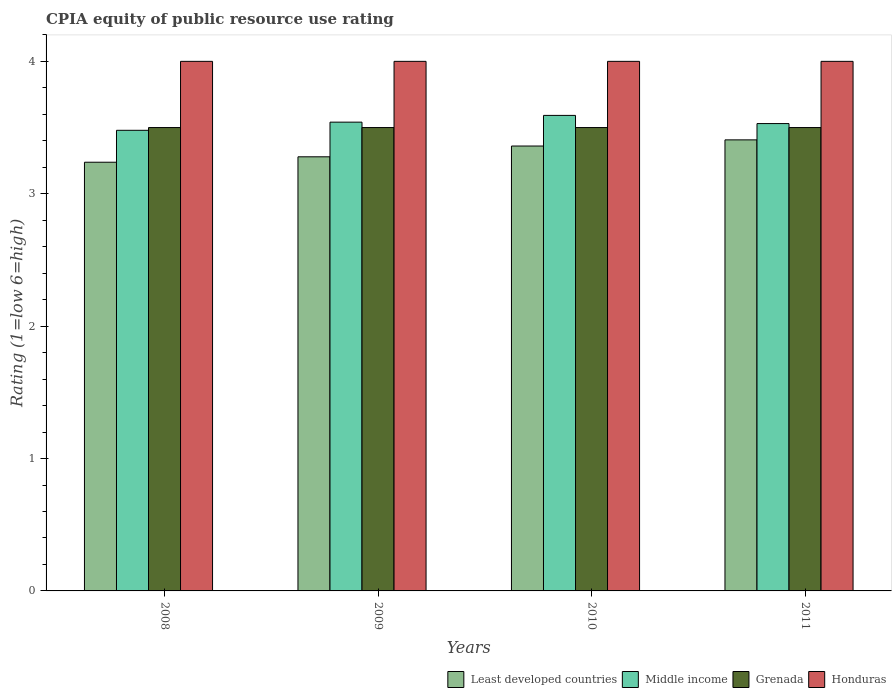Are the number of bars on each tick of the X-axis equal?
Your answer should be very brief. Yes. How many bars are there on the 3rd tick from the left?
Your response must be concise. 4. In how many cases, is the number of bars for a given year not equal to the number of legend labels?
Provide a succinct answer. 0. What is the CPIA rating in Least developed countries in 2011?
Your answer should be very brief. 3.41. Across all years, what is the maximum CPIA rating in Least developed countries?
Your answer should be very brief. 3.41. Across all years, what is the minimum CPIA rating in Honduras?
Provide a short and direct response. 4. What is the total CPIA rating in Honduras in the graph?
Your answer should be compact. 16. What is the difference between the CPIA rating in Least developed countries in 2010 and the CPIA rating in Grenada in 2009?
Keep it short and to the point. -0.14. What is the average CPIA rating in Honduras per year?
Offer a terse response. 4. In the year 2008, what is the difference between the CPIA rating in Least developed countries and CPIA rating in Honduras?
Keep it short and to the point. -0.76. In how many years, is the CPIA rating in Middle income greater than 0.4?
Keep it short and to the point. 4. What is the ratio of the CPIA rating in Honduras in 2008 to that in 2009?
Ensure brevity in your answer.  1. Is the CPIA rating in Least developed countries in 2009 less than that in 2011?
Offer a very short reply. Yes. Is the difference between the CPIA rating in Least developed countries in 2008 and 2010 greater than the difference between the CPIA rating in Honduras in 2008 and 2010?
Your answer should be very brief. No. What is the difference between the highest and the second highest CPIA rating in Middle income?
Give a very brief answer. 0.05. What is the difference between the highest and the lowest CPIA rating in Middle income?
Provide a succinct answer. 0.11. Is the sum of the CPIA rating in Honduras in 2009 and 2011 greater than the maximum CPIA rating in Least developed countries across all years?
Provide a short and direct response. Yes. What does the 3rd bar from the left in 2008 represents?
Make the answer very short. Grenada. What does the 1st bar from the right in 2011 represents?
Your response must be concise. Honduras. How many bars are there?
Offer a very short reply. 16. Does the graph contain grids?
Provide a succinct answer. No. Where does the legend appear in the graph?
Your answer should be very brief. Bottom right. How many legend labels are there?
Give a very brief answer. 4. What is the title of the graph?
Your answer should be compact. CPIA equity of public resource use rating. What is the label or title of the Y-axis?
Make the answer very short. Rating (1=low 6=high). What is the Rating (1=low 6=high) of Least developed countries in 2008?
Offer a very short reply. 3.24. What is the Rating (1=low 6=high) of Middle income in 2008?
Provide a succinct answer. 3.48. What is the Rating (1=low 6=high) of Grenada in 2008?
Give a very brief answer. 3.5. What is the Rating (1=low 6=high) in Honduras in 2008?
Your response must be concise. 4. What is the Rating (1=low 6=high) of Least developed countries in 2009?
Provide a succinct answer. 3.28. What is the Rating (1=low 6=high) of Middle income in 2009?
Ensure brevity in your answer.  3.54. What is the Rating (1=low 6=high) of Grenada in 2009?
Your answer should be compact. 3.5. What is the Rating (1=low 6=high) of Honduras in 2009?
Your answer should be compact. 4. What is the Rating (1=low 6=high) in Least developed countries in 2010?
Offer a terse response. 3.36. What is the Rating (1=low 6=high) of Middle income in 2010?
Your answer should be compact. 3.59. What is the Rating (1=low 6=high) of Honduras in 2010?
Offer a very short reply. 4. What is the Rating (1=low 6=high) in Least developed countries in 2011?
Offer a very short reply. 3.41. What is the Rating (1=low 6=high) in Middle income in 2011?
Your answer should be very brief. 3.53. What is the Rating (1=low 6=high) of Grenada in 2011?
Offer a very short reply. 3.5. Across all years, what is the maximum Rating (1=low 6=high) in Least developed countries?
Ensure brevity in your answer.  3.41. Across all years, what is the maximum Rating (1=low 6=high) of Middle income?
Provide a short and direct response. 3.59. Across all years, what is the maximum Rating (1=low 6=high) in Grenada?
Make the answer very short. 3.5. Across all years, what is the minimum Rating (1=low 6=high) of Least developed countries?
Offer a very short reply. 3.24. Across all years, what is the minimum Rating (1=low 6=high) of Middle income?
Offer a terse response. 3.48. Across all years, what is the minimum Rating (1=low 6=high) in Grenada?
Provide a succinct answer. 3.5. Across all years, what is the minimum Rating (1=low 6=high) of Honduras?
Keep it short and to the point. 4. What is the total Rating (1=low 6=high) in Least developed countries in the graph?
Make the answer very short. 13.28. What is the total Rating (1=low 6=high) in Middle income in the graph?
Offer a terse response. 14.14. What is the total Rating (1=low 6=high) of Honduras in the graph?
Keep it short and to the point. 16. What is the difference between the Rating (1=low 6=high) of Least developed countries in 2008 and that in 2009?
Make the answer very short. -0.04. What is the difference between the Rating (1=low 6=high) of Middle income in 2008 and that in 2009?
Your answer should be very brief. -0.06. What is the difference between the Rating (1=low 6=high) of Honduras in 2008 and that in 2009?
Give a very brief answer. 0. What is the difference between the Rating (1=low 6=high) of Least developed countries in 2008 and that in 2010?
Offer a very short reply. -0.12. What is the difference between the Rating (1=low 6=high) in Middle income in 2008 and that in 2010?
Offer a very short reply. -0.11. What is the difference between the Rating (1=low 6=high) in Honduras in 2008 and that in 2010?
Your answer should be compact. 0. What is the difference between the Rating (1=low 6=high) of Least developed countries in 2008 and that in 2011?
Provide a short and direct response. -0.17. What is the difference between the Rating (1=low 6=high) in Middle income in 2008 and that in 2011?
Offer a terse response. -0.05. What is the difference between the Rating (1=low 6=high) in Grenada in 2008 and that in 2011?
Give a very brief answer. 0. What is the difference between the Rating (1=low 6=high) in Least developed countries in 2009 and that in 2010?
Your response must be concise. -0.08. What is the difference between the Rating (1=low 6=high) in Middle income in 2009 and that in 2010?
Your answer should be compact. -0.05. What is the difference between the Rating (1=low 6=high) of Least developed countries in 2009 and that in 2011?
Offer a terse response. -0.13. What is the difference between the Rating (1=low 6=high) in Middle income in 2009 and that in 2011?
Your answer should be very brief. 0.01. What is the difference between the Rating (1=low 6=high) in Grenada in 2009 and that in 2011?
Your answer should be compact. 0. What is the difference between the Rating (1=low 6=high) of Honduras in 2009 and that in 2011?
Your response must be concise. 0. What is the difference between the Rating (1=low 6=high) in Least developed countries in 2010 and that in 2011?
Offer a very short reply. -0.05. What is the difference between the Rating (1=low 6=high) in Middle income in 2010 and that in 2011?
Keep it short and to the point. 0.06. What is the difference between the Rating (1=low 6=high) in Grenada in 2010 and that in 2011?
Keep it short and to the point. 0. What is the difference between the Rating (1=low 6=high) of Honduras in 2010 and that in 2011?
Keep it short and to the point. 0. What is the difference between the Rating (1=low 6=high) of Least developed countries in 2008 and the Rating (1=low 6=high) of Middle income in 2009?
Give a very brief answer. -0.3. What is the difference between the Rating (1=low 6=high) in Least developed countries in 2008 and the Rating (1=low 6=high) in Grenada in 2009?
Your response must be concise. -0.26. What is the difference between the Rating (1=low 6=high) in Least developed countries in 2008 and the Rating (1=low 6=high) in Honduras in 2009?
Your response must be concise. -0.76. What is the difference between the Rating (1=low 6=high) in Middle income in 2008 and the Rating (1=low 6=high) in Grenada in 2009?
Give a very brief answer. -0.02. What is the difference between the Rating (1=low 6=high) in Middle income in 2008 and the Rating (1=low 6=high) in Honduras in 2009?
Your response must be concise. -0.52. What is the difference between the Rating (1=low 6=high) of Least developed countries in 2008 and the Rating (1=low 6=high) of Middle income in 2010?
Your answer should be very brief. -0.35. What is the difference between the Rating (1=low 6=high) of Least developed countries in 2008 and the Rating (1=low 6=high) of Grenada in 2010?
Give a very brief answer. -0.26. What is the difference between the Rating (1=low 6=high) of Least developed countries in 2008 and the Rating (1=low 6=high) of Honduras in 2010?
Offer a terse response. -0.76. What is the difference between the Rating (1=low 6=high) in Middle income in 2008 and the Rating (1=low 6=high) in Grenada in 2010?
Provide a succinct answer. -0.02. What is the difference between the Rating (1=low 6=high) in Middle income in 2008 and the Rating (1=low 6=high) in Honduras in 2010?
Offer a terse response. -0.52. What is the difference between the Rating (1=low 6=high) of Least developed countries in 2008 and the Rating (1=low 6=high) of Middle income in 2011?
Ensure brevity in your answer.  -0.29. What is the difference between the Rating (1=low 6=high) in Least developed countries in 2008 and the Rating (1=low 6=high) in Grenada in 2011?
Give a very brief answer. -0.26. What is the difference between the Rating (1=low 6=high) in Least developed countries in 2008 and the Rating (1=low 6=high) in Honduras in 2011?
Ensure brevity in your answer.  -0.76. What is the difference between the Rating (1=low 6=high) of Middle income in 2008 and the Rating (1=low 6=high) of Grenada in 2011?
Ensure brevity in your answer.  -0.02. What is the difference between the Rating (1=low 6=high) in Middle income in 2008 and the Rating (1=low 6=high) in Honduras in 2011?
Offer a very short reply. -0.52. What is the difference between the Rating (1=low 6=high) in Grenada in 2008 and the Rating (1=low 6=high) in Honduras in 2011?
Make the answer very short. -0.5. What is the difference between the Rating (1=low 6=high) in Least developed countries in 2009 and the Rating (1=low 6=high) in Middle income in 2010?
Offer a very short reply. -0.31. What is the difference between the Rating (1=low 6=high) of Least developed countries in 2009 and the Rating (1=low 6=high) of Grenada in 2010?
Your response must be concise. -0.22. What is the difference between the Rating (1=low 6=high) in Least developed countries in 2009 and the Rating (1=low 6=high) in Honduras in 2010?
Your answer should be compact. -0.72. What is the difference between the Rating (1=low 6=high) in Middle income in 2009 and the Rating (1=low 6=high) in Grenada in 2010?
Ensure brevity in your answer.  0.04. What is the difference between the Rating (1=low 6=high) of Middle income in 2009 and the Rating (1=low 6=high) of Honduras in 2010?
Offer a terse response. -0.46. What is the difference between the Rating (1=low 6=high) in Least developed countries in 2009 and the Rating (1=low 6=high) in Middle income in 2011?
Make the answer very short. -0.25. What is the difference between the Rating (1=low 6=high) of Least developed countries in 2009 and the Rating (1=low 6=high) of Grenada in 2011?
Your answer should be compact. -0.22. What is the difference between the Rating (1=low 6=high) of Least developed countries in 2009 and the Rating (1=low 6=high) of Honduras in 2011?
Give a very brief answer. -0.72. What is the difference between the Rating (1=low 6=high) of Middle income in 2009 and the Rating (1=low 6=high) of Grenada in 2011?
Provide a succinct answer. 0.04. What is the difference between the Rating (1=low 6=high) of Middle income in 2009 and the Rating (1=low 6=high) of Honduras in 2011?
Provide a short and direct response. -0.46. What is the difference between the Rating (1=low 6=high) of Grenada in 2009 and the Rating (1=low 6=high) of Honduras in 2011?
Make the answer very short. -0.5. What is the difference between the Rating (1=low 6=high) of Least developed countries in 2010 and the Rating (1=low 6=high) of Middle income in 2011?
Your answer should be compact. -0.17. What is the difference between the Rating (1=low 6=high) of Least developed countries in 2010 and the Rating (1=low 6=high) of Grenada in 2011?
Offer a terse response. -0.14. What is the difference between the Rating (1=low 6=high) in Least developed countries in 2010 and the Rating (1=low 6=high) in Honduras in 2011?
Your answer should be compact. -0.64. What is the difference between the Rating (1=low 6=high) of Middle income in 2010 and the Rating (1=low 6=high) of Grenada in 2011?
Provide a succinct answer. 0.09. What is the difference between the Rating (1=low 6=high) of Middle income in 2010 and the Rating (1=low 6=high) of Honduras in 2011?
Keep it short and to the point. -0.41. What is the difference between the Rating (1=low 6=high) in Grenada in 2010 and the Rating (1=low 6=high) in Honduras in 2011?
Make the answer very short. -0.5. What is the average Rating (1=low 6=high) of Least developed countries per year?
Your response must be concise. 3.32. What is the average Rating (1=low 6=high) of Middle income per year?
Make the answer very short. 3.54. What is the average Rating (1=low 6=high) of Honduras per year?
Offer a very short reply. 4. In the year 2008, what is the difference between the Rating (1=low 6=high) in Least developed countries and Rating (1=low 6=high) in Middle income?
Provide a succinct answer. -0.24. In the year 2008, what is the difference between the Rating (1=low 6=high) of Least developed countries and Rating (1=low 6=high) of Grenada?
Your response must be concise. -0.26. In the year 2008, what is the difference between the Rating (1=low 6=high) of Least developed countries and Rating (1=low 6=high) of Honduras?
Provide a succinct answer. -0.76. In the year 2008, what is the difference between the Rating (1=low 6=high) in Middle income and Rating (1=low 6=high) in Grenada?
Offer a terse response. -0.02. In the year 2008, what is the difference between the Rating (1=low 6=high) in Middle income and Rating (1=low 6=high) in Honduras?
Provide a succinct answer. -0.52. In the year 2008, what is the difference between the Rating (1=low 6=high) in Grenada and Rating (1=low 6=high) in Honduras?
Make the answer very short. -0.5. In the year 2009, what is the difference between the Rating (1=low 6=high) of Least developed countries and Rating (1=low 6=high) of Middle income?
Offer a very short reply. -0.26. In the year 2009, what is the difference between the Rating (1=low 6=high) of Least developed countries and Rating (1=low 6=high) of Grenada?
Make the answer very short. -0.22. In the year 2009, what is the difference between the Rating (1=low 6=high) in Least developed countries and Rating (1=low 6=high) in Honduras?
Make the answer very short. -0.72. In the year 2009, what is the difference between the Rating (1=low 6=high) in Middle income and Rating (1=low 6=high) in Grenada?
Ensure brevity in your answer.  0.04. In the year 2009, what is the difference between the Rating (1=low 6=high) of Middle income and Rating (1=low 6=high) of Honduras?
Your response must be concise. -0.46. In the year 2010, what is the difference between the Rating (1=low 6=high) in Least developed countries and Rating (1=low 6=high) in Middle income?
Your answer should be very brief. -0.23. In the year 2010, what is the difference between the Rating (1=low 6=high) of Least developed countries and Rating (1=low 6=high) of Grenada?
Your response must be concise. -0.14. In the year 2010, what is the difference between the Rating (1=low 6=high) in Least developed countries and Rating (1=low 6=high) in Honduras?
Make the answer very short. -0.64. In the year 2010, what is the difference between the Rating (1=low 6=high) of Middle income and Rating (1=low 6=high) of Grenada?
Your response must be concise. 0.09. In the year 2010, what is the difference between the Rating (1=low 6=high) in Middle income and Rating (1=low 6=high) in Honduras?
Your answer should be compact. -0.41. In the year 2011, what is the difference between the Rating (1=low 6=high) of Least developed countries and Rating (1=low 6=high) of Middle income?
Offer a terse response. -0.12. In the year 2011, what is the difference between the Rating (1=low 6=high) in Least developed countries and Rating (1=low 6=high) in Grenada?
Offer a very short reply. -0.09. In the year 2011, what is the difference between the Rating (1=low 6=high) in Least developed countries and Rating (1=low 6=high) in Honduras?
Offer a terse response. -0.59. In the year 2011, what is the difference between the Rating (1=low 6=high) in Middle income and Rating (1=low 6=high) in Grenada?
Provide a succinct answer. 0.03. In the year 2011, what is the difference between the Rating (1=low 6=high) in Middle income and Rating (1=low 6=high) in Honduras?
Ensure brevity in your answer.  -0.47. What is the ratio of the Rating (1=low 6=high) in Least developed countries in 2008 to that in 2009?
Offer a very short reply. 0.99. What is the ratio of the Rating (1=low 6=high) of Middle income in 2008 to that in 2009?
Make the answer very short. 0.98. What is the ratio of the Rating (1=low 6=high) in Least developed countries in 2008 to that in 2010?
Your answer should be compact. 0.96. What is the ratio of the Rating (1=low 6=high) of Middle income in 2008 to that in 2010?
Give a very brief answer. 0.97. What is the ratio of the Rating (1=low 6=high) in Grenada in 2008 to that in 2010?
Keep it short and to the point. 1. What is the ratio of the Rating (1=low 6=high) of Least developed countries in 2008 to that in 2011?
Your answer should be very brief. 0.95. What is the ratio of the Rating (1=low 6=high) in Middle income in 2008 to that in 2011?
Keep it short and to the point. 0.99. What is the ratio of the Rating (1=low 6=high) in Grenada in 2008 to that in 2011?
Your answer should be very brief. 1. What is the ratio of the Rating (1=low 6=high) of Honduras in 2008 to that in 2011?
Give a very brief answer. 1. What is the ratio of the Rating (1=low 6=high) of Least developed countries in 2009 to that in 2010?
Make the answer very short. 0.98. What is the ratio of the Rating (1=low 6=high) of Middle income in 2009 to that in 2010?
Offer a very short reply. 0.99. What is the ratio of the Rating (1=low 6=high) in Grenada in 2009 to that in 2010?
Make the answer very short. 1. What is the ratio of the Rating (1=low 6=high) of Least developed countries in 2009 to that in 2011?
Provide a short and direct response. 0.96. What is the ratio of the Rating (1=low 6=high) in Honduras in 2009 to that in 2011?
Make the answer very short. 1. What is the ratio of the Rating (1=low 6=high) of Least developed countries in 2010 to that in 2011?
Give a very brief answer. 0.99. What is the ratio of the Rating (1=low 6=high) of Middle income in 2010 to that in 2011?
Provide a succinct answer. 1.02. What is the ratio of the Rating (1=low 6=high) in Honduras in 2010 to that in 2011?
Keep it short and to the point. 1. What is the difference between the highest and the second highest Rating (1=low 6=high) in Least developed countries?
Your answer should be very brief. 0.05. What is the difference between the highest and the second highest Rating (1=low 6=high) of Middle income?
Your answer should be compact. 0.05. What is the difference between the highest and the lowest Rating (1=low 6=high) in Least developed countries?
Give a very brief answer. 0.17. What is the difference between the highest and the lowest Rating (1=low 6=high) of Middle income?
Your answer should be compact. 0.11. 